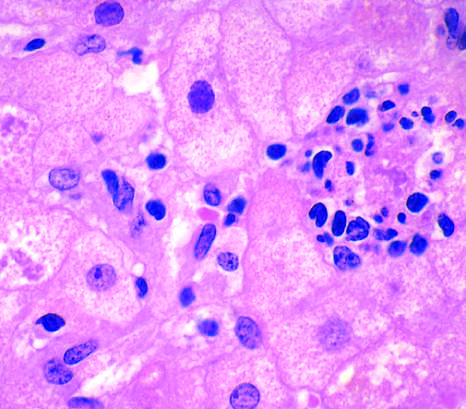s the fibrous capsule associated with chronic alcohol use?
Answer the question using a single word or phrase. No 